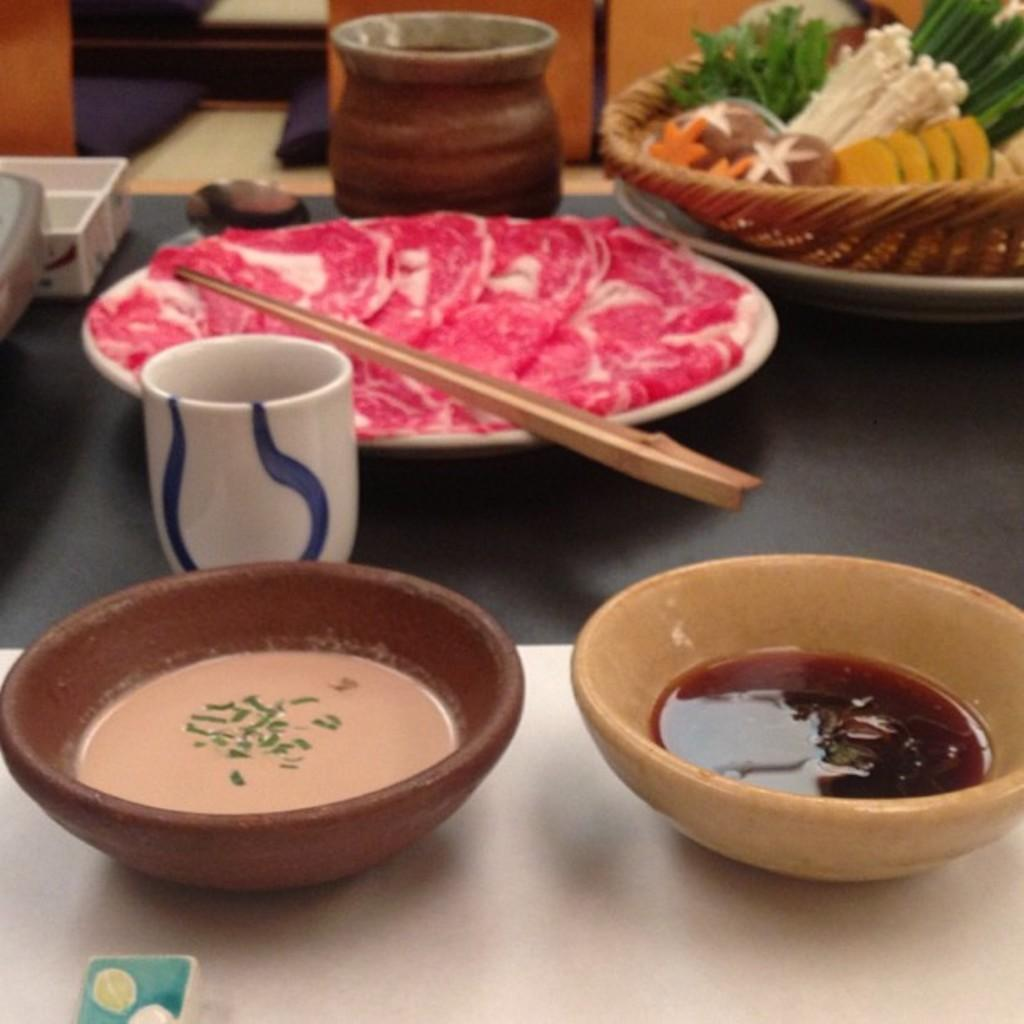What type of containers are present in the image? There are bowls in the image. What is inside the bowls? The bowls contain soup and curry. What is on the plate in the image? The plate has chopsticks. What is present in the basket in the image? The basket contains food items. What type of beverage container is on the table in the image? There is a glass on the table in the image. What event is taking place in the image? There is no specific event taking place in the image; it simply shows bowls, a plate, a basket, and a glass on a table. Is anyone reading in the image? There is no indication of anyone reading in the image. 